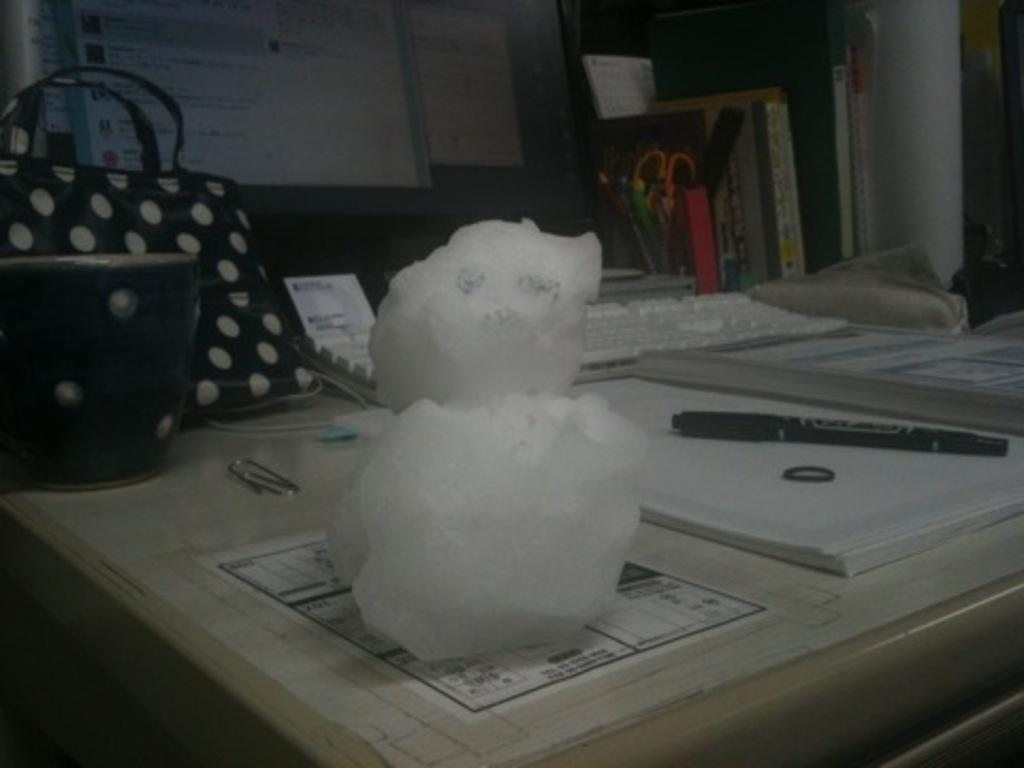What piece of furniture is present in the image? There is a table in the image. What is placed on the table? There is a cup, a bag, a keyboard, a computer, a book, a pen, and a white object in the shape of a snowman on the table. What type of electronic device is on the table? There is a computer on the table. What stationery item is on the table? There is a pen on the table. What decorative object is on the table? There is a white object in the shape of a snowman on the table. What can be seen in the background of the image? There are many items visible in the background. How does the distribution of units in the image affect the mind? The image does not depict any units or discuss the mind, so this question cannot be answered based on the information provided. 